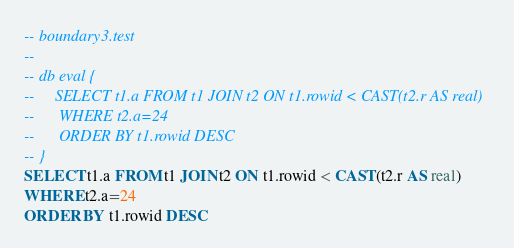Convert code to text. <code><loc_0><loc_0><loc_500><loc_500><_SQL_>-- boundary3.test
-- 
-- db eval {
--     SELECT t1.a FROM t1 JOIN t2 ON t1.rowid < CAST(t2.r AS real)
--      WHERE t2.a=24
--      ORDER BY t1.rowid DESC
-- }
SELECT t1.a FROM t1 JOIN t2 ON t1.rowid < CAST(t2.r AS real)
WHERE t2.a=24
ORDER BY t1.rowid DESC</code> 